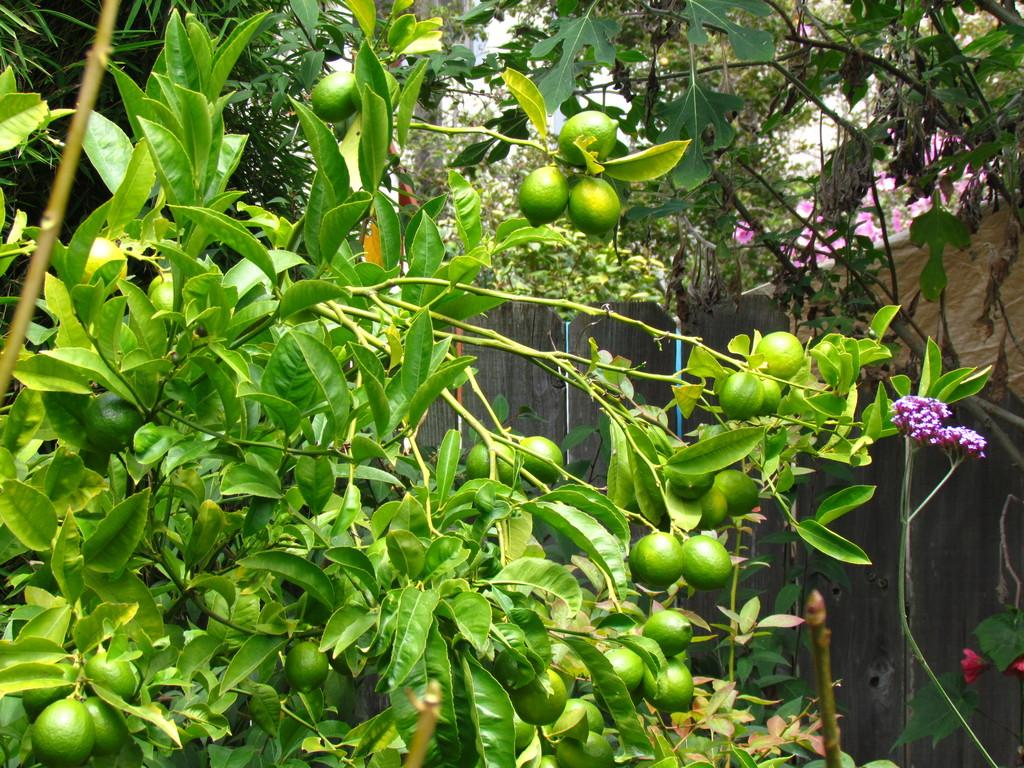What type of fruit is growing on the plant in the image? There are lemons on the plant in the image. What other type of plant life is present on the plant in the image? There are flowers on the plant in the image. What other plants can be seen in the image? There are other plants visible in the image. What type of larger vegetation is visible in the image? There are trees visible in the image. What type of payment method is accepted by the rail company in the image? There is no rail company or payment method present in the image; it features a plant with lemons and flowers. What type of organization is responsible for maintaining the trees in the image? There is no organization responsible for maintaining the trees in the image; they are simply visible in the background. 